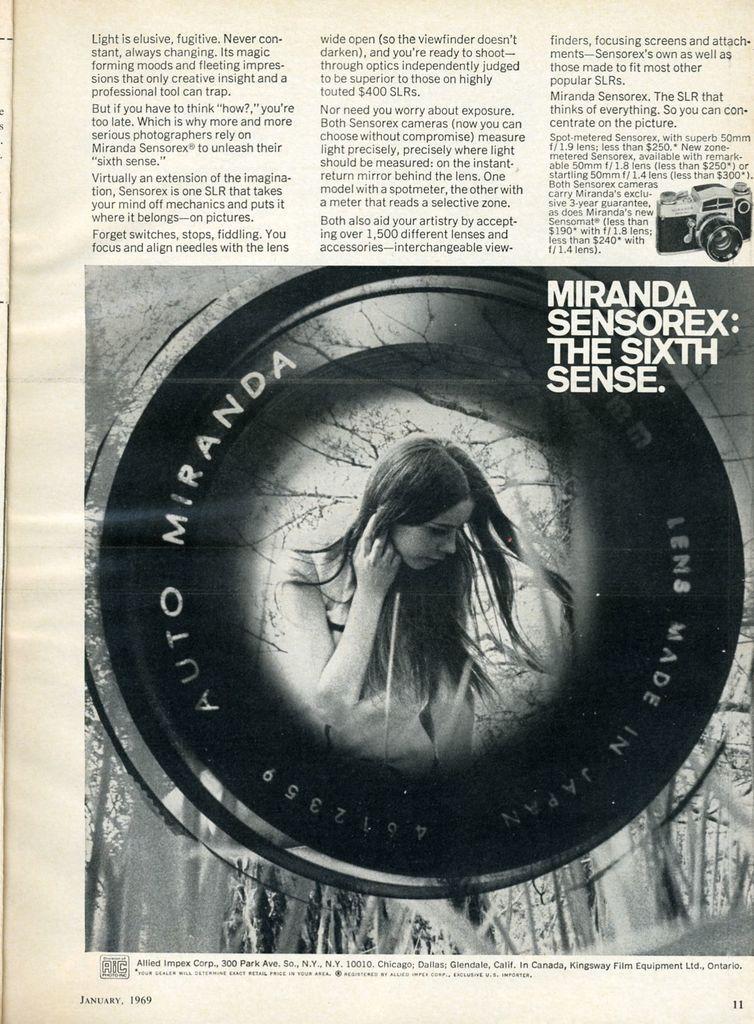Can you describe this image briefly? In this image there is a paper having an image and some text on it. In the picture there is a woman. Top of the image there is some text. Right side there is a camera image. 